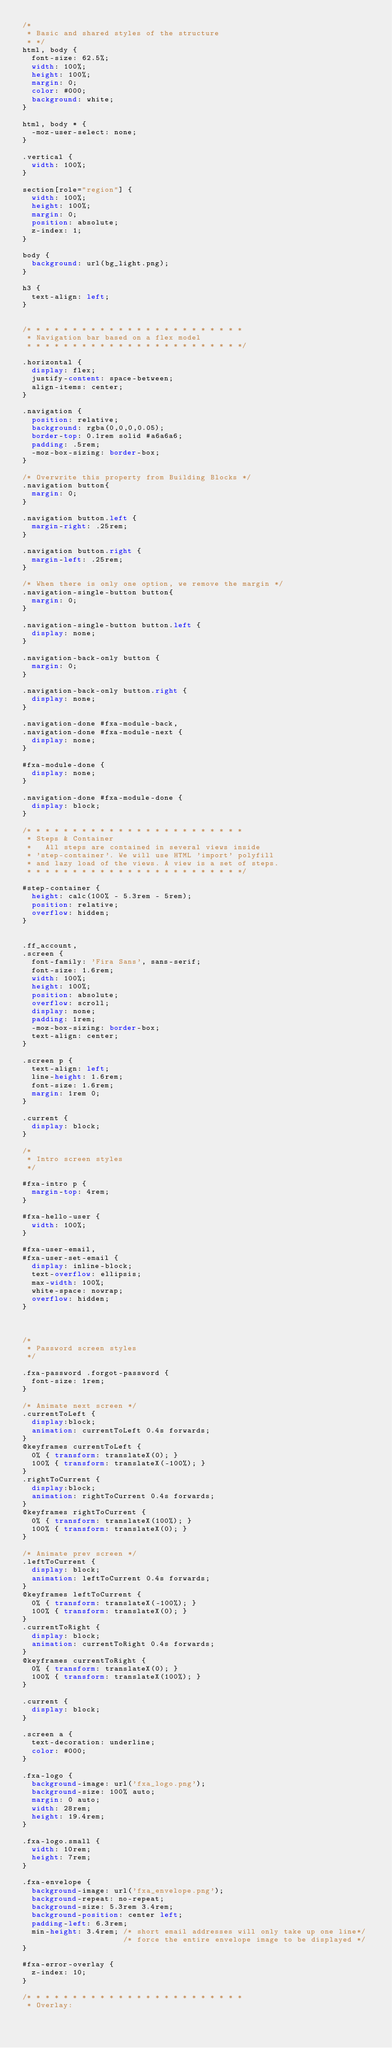<code> <loc_0><loc_0><loc_500><loc_500><_CSS_>/*
 * Basic and shared styles of the structure
 * */
html, body {
  font-size: 62.5%;
  width: 100%;
  height: 100%;
  margin: 0;
  color: #000;
  background: white;
}

html, body * {
  -moz-user-select: none;
}

.vertical {
  width: 100%;
}

section[role="region"] {
  width: 100%;
  height: 100%;
  margin: 0;
  position: absolute;
  z-index: 1;
}

body {
  background: url(bg_light.png);
}

h3 {
  text-align: left;
}


/* * * * * * * * * * * * * * * * * * * * * * * *
 * Navigation bar based on a flex model
 * * * * * * * * * * * * * * * * * * * * * * * */

.horizontal {
  display: flex;
  justify-content: space-between;
  align-items: center;
}

.navigation {
  position: relative;
  background: rgba(0,0,0,0.05);
  border-top: 0.1rem solid #a6a6a6;
  padding: .5rem;
  -moz-box-sizing: border-box;
}

/* Overwrite this property from Building Blocks */
.navigation button{
  margin: 0;
}

.navigation button.left {
  margin-right: .25rem;
}

.navigation button.right {
  margin-left: .25rem;
}

/* When there is only one option, we remove the margin */
.navigation-single-button button{
  margin: 0;
}

.navigation-single-button button.left {
  display: none;
}

.navigation-back-only button {
  margin: 0;
}

.navigation-back-only button.right {
  display: none;
}

.navigation-done #fxa-module-back,
.navigation-done #fxa-module-next {
  display: none;
}

#fxa-module-done {
  display: none;
}

.navigation-done #fxa-module-done {
  display: block;
}

/* * * * * * * * * * * * * * * * * * * * * * * *
 * Steps & Container
 *   All steps are contained in several views inside
 * 'step-container'. We will use HTML 'import' polyfill
 * and lazy load of the views. A view is a set of steps.
 * * * * * * * * * * * * * * * * * * * * * * * */

#step-container {
  height: calc(100% - 5.3rem - 5rem);
  position: relative;
  overflow: hidden;
}


.ff_account,
.screen {
  font-family: 'Fira Sans', sans-serif;
  font-size: 1.6rem;
  width: 100%;
  height: 100%;
  position: absolute;
  overflow: scroll;
  display: none;
  padding: 1rem;
  -moz-box-sizing: border-box;
  text-align: center;
}

.screen p {
  text-align: left;
  line-height: 1.6rem;
  font-size: 1.6rem;
  margin: 1rem 0;
}

.current {
  display: block;
}

/*
 * Intro screen styles
 */

#fxa-intro p {
  margin-top: 4rem;
}

#fxa-hello-user {
  width: 100%;
}

#fxa-user-email,
#fxa-user-set-email {
  display: inline-block;
  text-overflow: ellipsis;
  max-width: 100%;
  white-space: nowrap;
  overflow: hidden;
}



/*
 * Password screen styles
 */

.fxa-password .forgot-password {
  font-size: 1rem;
}

/* Animate next screen */
.currentToLeft {
  display:block;
  animation: currentToLeft 0.4s forwards;
}
@keyframes currentToLeft {
  0% { transform: translateX(0); }
  100% { transform: translateX(-100%); }
}
.rightToCurrent {
  display:block;
  animation: rightToCurrent 0.4s forwards;
}
@keyframes rightToCurrent {
  0% { transform: translateX(100%); }
  100% { transform: translateX(0); }
}

/* Animate prev screen */
.leftToCurrent {
  display: block;
  animation: leftToCurrent 0.4s forwards;
}
@keyframes leftToCurrent {
  0% { transform: translateX(-100%); }
  100% { transform: translateX(0); }
}
.currentToRight {
  display: block;
  animation: currentToRight 0.4s forwards;
}
@keyframes currentToRight {
  0% { transform: translateX(0); }
  100% { transform: translateX(100%); }
}

.current {
  display: block;
}

.screen a {
  text-decoration: underline;
  color: #000;
}

.fxa-logo {
  background-image: url('fxa_logo.png');
  background-size: 100% auto;
  margin: 0 auto;
  width: 28rem;
  height: 19.4rem;
}

.fxa-logo.small {
  width: 10rem;
  height: 7rem;
}

.fxa-envelope {
  background-image: url('fxa_envelope.png');
  background-repeat: no-repeat;
  background-size: 5.3rem 3.4rem;
  background-position: center left;
  padding-left: 6.3rem;
  min-height: 3.4rem; /* short email addresses will only take up one line*/
                      /* force the entire envelope image to be displayed */
}

#fxa-error-overlay {
  z-index: 10;
}

/* * * * * * * * * * * * * * * * * * * * * * * *
 * Overlay:</code> 